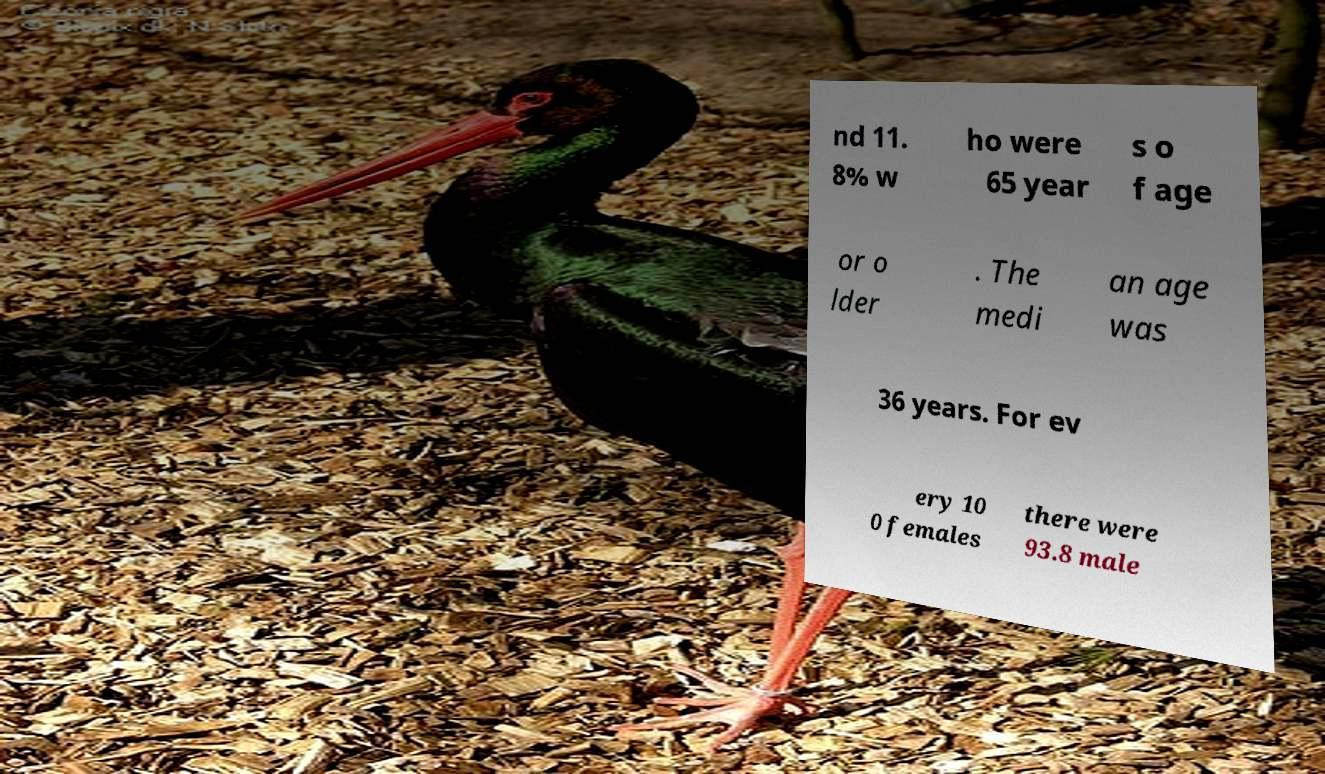Please read and relay the text visible in this image. What does it say? nd 11. 8% w ho were 65 year s o f age or o lder . The medi an age was 36 years. For ev ery 10 0 females there were 93.8 male 